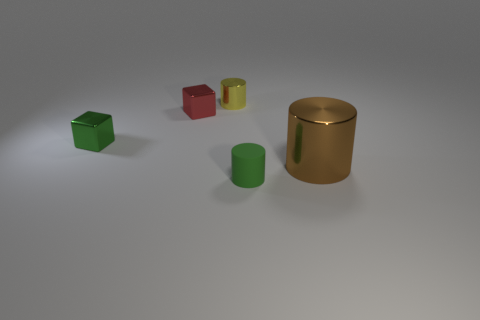Add 1 red blocks. How many objects exist? 6 Subtract all cylinders. How many objects are left? 2 Add 1 brown cylinders. How many brown cylinders are left? 2 Add 4 big brown objects. How many big brown objects exist? 5 Subtract 1 red cubes. How many objects are left? 4 Subtract all yellow cubes. Subtract all small shiny cylinders. How many objects are left? 4 